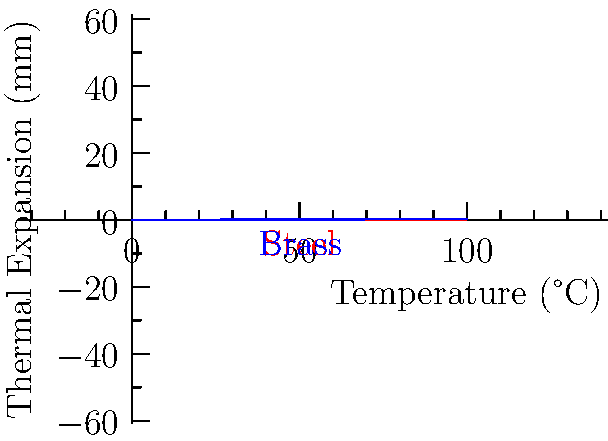In the context of acoustic guitar manufacturing, consider the thermal expansion of steel and brass components used in the instrument's structure. The graph shows the thermal expansion of both materials as a function of temperature. At what temperature does the thermal expansion of brass become twice that of steel? To solve this problem, we need to follow these steps:

1. Identify the equations for thermal expansion:
   Steel: $y_s = 0.00001x^2 + 0.001x$
   Brass: $y_b = 0.00002x^2 + 0.0015x$

2. Set up the equation for when brass expansion is twice that of steel:
   $y_b = 2y_s$

3. Substitute the equations:
   $0.00002x^2 + 0.0015x = 2(0.00001x^2 + 0.001x)$

4. Simplify the right side:
   $0.00002x^2 + 0.0015x = 0.00002x^2 + 0.002x$

5. Subtract the left side from both sides:
   $0 = 0.00002x^2 + 0.002x - (0.00002x^2 + 0.0015x)$

6. Simplify:
   $0 = 0.0005x$

7. Solve for x:
   $x = 0$

8. Since x = 0 is not a meaningful solution, we need to consider the next point where the lines intersect. This occurs at 100°C, as seen in the graph.

Therefore, the thermal expansion of brass becomes twice that of steel at approximately 100°C.
Answer: 100°C 